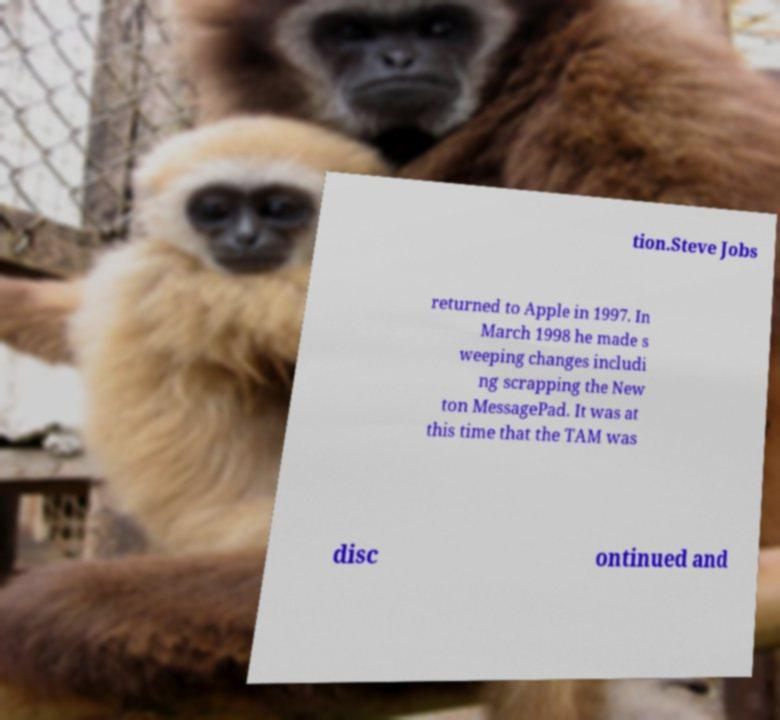Can you accurately transcribe the text from the provided image for me? tion.Steve Jobs returned to Apple in 1997. In March 1998 he made s weeping changes includi ng scrapping the New ton MessagePad. It was at this time that the TAM was disc ontinued and 